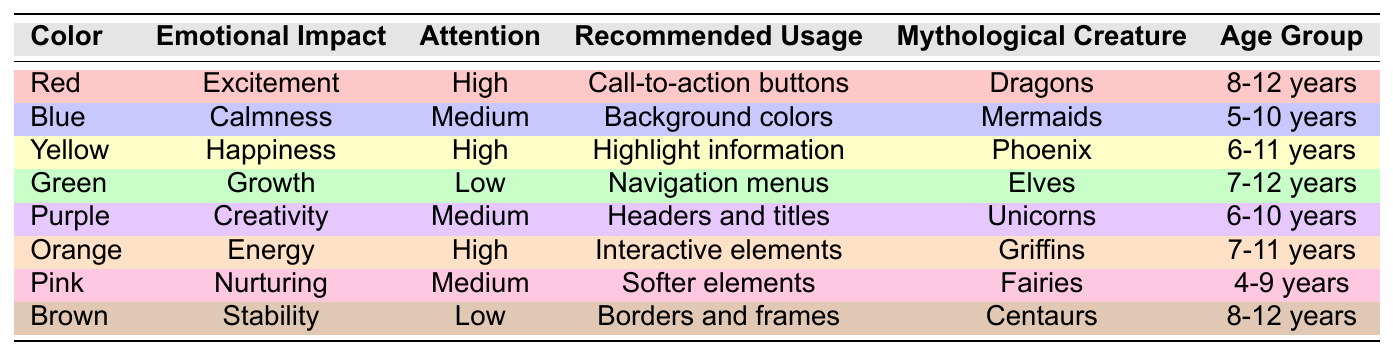What is the emotional impact of the color Yellow? The table indicates that the emotional impact of Yellow is "Happiness."
Answer: Happiness Which color has the highest attention level and what is its recommended usage? The table shows that both Red and Yellow have a "High" attention level. Red is recommended for "Call-to-action buttons," while Yellow is recommended to "Highlight important information."
Answer: Red for call-to-action buttons Is Pink suitable for children aged 11 years? Pink is recommended for the age group of "4-9 years," which means it is not suitable for children aged 11 years.
Answer: No Which mythological creature is associated with the color Green? According to the table, the color Green is associated with "Elves."
Answer: Elves What colors are suitable for the age group 6-10 years? The table lists Purple and Yellow as suitable colors for the age group 6-10 years.
Answer: Purple and Yellow What is the emotional impact of all colors with a high attention level? The high attention level colors are Red, Yellow, and Orange, which correspond to "Excitement," "Happiness," and "Energy," respectively.
Answer: Excitement, Happiness, Energy Are there any colors that have a low attention level? Yes, both Green and Brown have a "Low" attention level according to the data.
Answer: Yes Which color is recommended for navigation menus? The table states that Green is recommended for "Navigation menus."
Answer: Green How many colors are associated with mythological creatures named after fantastical beasts? The table includes Red (Dragons), Yellow (Phoenix), and Orange (Griffins) as colors associated with fantastical beasts, totaling three.
Answer: 3 What color should be used for headers and titles, and what is its emotional impact? The table specifies that Purple should be used for "Headers and titles" and has an emotional impact of "Creativity."
Answer: Purple, Creativity Which color has a nurturing emotional impact and for which age group is it suitable? The table indicates that Pink has a nurturing emotional impact and is suitable for the age group of "4-9 years."
Answer: Pink, 4-9 years How many colors in the table are associated with an age group of 8-12 years? The colors associated with the age group 8-12 years are Red and Brown, totaling two colors.
Answer: 2 